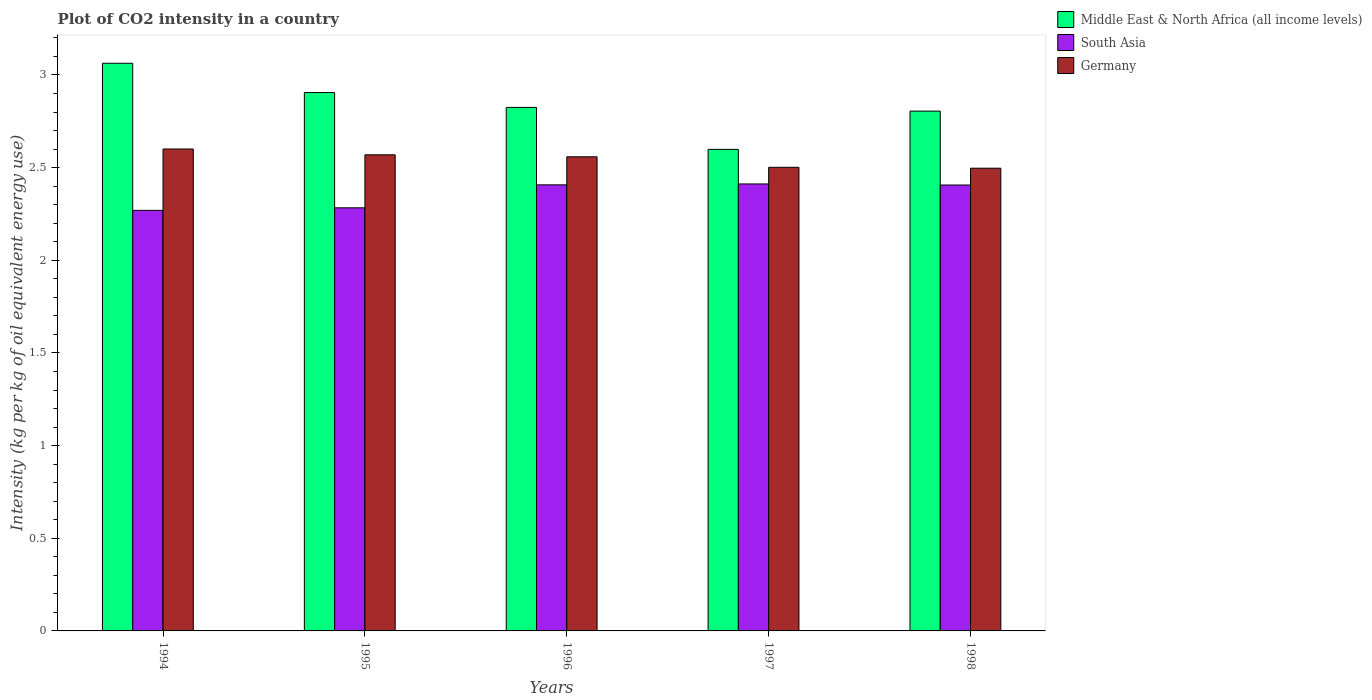How many groups of bars are there?
Your response must be concise. 5. How many bars are there on the 3rd tick from the left?
Your answer should be compact. 3. How many bars are there on the 5th tick from the right?
Your answer should be compact. 3. What is the label of the 1st group of bars from the left?
Offer a very short reply. 1994. What is the CO2 intensity in in Germany in 1996?
Your answer should be compact. 2.56. Across all years, what is the maximum CO2 intensity in in South Asia?
Your answer should be very brief. 2.41. Across all years, what is the minimum CO2 intensity in in Middle East & North Africa (all income levels)?
Offer a very short reply. 2.6. In which year was the CO2 intensity in in South Asia maximum?
Keep it short and to the point. 1997. What is the total CO2 intensity in in Germany in the graph?
Your answer should be compact. 12.73. What is the difference between the CO2 intensity in in Germany in 1995 and that in 1998?
Make the answer very short. 0.07. What is the difference between the CO2 intensity in in Germany in 1998 and the CO2 intensity in in South Asia in 1995?
Give a very brief answer. 0.21. What is the average CO2 intensity in in South Asia per year?
Ensure brevity in your answer.  2.36. In the year 1995, what is the difference between the CO2 intensity in in Middle East & North Africa (all income levels) and CO2 intensity in in South Asia?
Your response must be concise. 0.62. In how many years, is the CO2 intensity in in Germany greater than 1.1 kg?
Provide a succinct answer. 5. What is the ratio of the CO2 intensity in in Middle East & North Africa (all income levels) in 1995 to that in 1996?
Make the answer very short. 1.03. Is the CO2 intensity in in South Asia in 1997 less than that in 1998?
Ensure brevity in your answer.  No. What is the difference between the highest and the second highest CO2 intensity in in Middle East & North Africa (all income levels)?
Provide a short and direct response. 0.16. What is the difference between the highest and the lowest CO2 intensity in in Middle East & North Africa (all income levels)?
Your response must be concise. 0.46. What does the 3rd bar from the left in 1996 represents?
Your answer should be very brief. Germany. What does the 3rd bar from the right in 1997 represents?
Your answer should be very brief. Middle East & North Africa (all income levels). How many years are there in the graph?
Provide a succinct answer. 5. Are the values on the major ticks of Y-axis written in scientific E-notation?
Make the answer very short. No. What is the title of the graph?
Provide a short and direct response. Plot of CO2 intensity in a country. Does "Channel Islands" appear as one of the legend labels in the graph?
Provide a succinct answer. No. What is the label or title of the X-axis?
Your answer should be very brief. Years. What is the label or title of the Y-axis?
Offer a terse response. Intensity (kg per kg of oil equivalent energy use). What is the Intensity (kg per kg of oil equivalent energy use) in Middle East & North Africa (all income levels) in 1994?
Your answer should be compact. 3.06. What is the Intensity (kg per kg of oil equivalent energy use) in South Asia in 1994?
Keep it short and to the point. 2.27. What is the Intensity (kg per kg of oil equivalent energy use) in Germany in 1994?
Ensure brevity in your answer.  2.6. What is the Intensity (kg per kg of oil equivalent energy use) of Middle East & North Africa (all income levels) in 1995?
Give a very brief answer. 2.9. What is the Intensity (kg per kg of oil equivalent energy use) of South Asia in 1995?
Your answer should be very brief. 2.28. What is the Intensity (kg per kg of oil equivalent energy use) of Germany in 1995?
Your response must be concise. 2.57. What is the Intensity (kg per kg of oil equivalent energy use) of Middle East & North Africa (all income levels) in 1996?
Make the answer very short. 2.82. What is the Intensity (kg per kg of oil equivalent energy use) of South Asia in 1996?
Make the answer very short. 2.41. What is the Intensity (kg per kg of oil equivalent energy use) in Germany in 1996?
Your response must be concise. 2.56. What is the Intensity (kg per kg of oil equivalent energy use) of Middle East & North Africa (all income levels) in 1997?
Ensure brevity in your answer.  2.6. What is the Intensity (kg per kg of oil equivalent energy use) in South Asia in 1997?
Provide a succinct answer. 2.41. What is the Intensity (kg per kg of oil equivalent energy use) of Germany in 1997?
Your answer should be compact. 2.5. What is the Intensity (kg per kg of oil equivalent energy use) in Middle East & North Africa (all income levels) in 1998?
Offer a very short reply. 2.81. What is the Intensity (kg per kg of oil equivalent energy use) of South Asia in 1998?
Give a very brief answer. 2.41. What is the Intensity (kg per kg of oil equivalent energy use) in Germany in 1998?
Keep it short and to the point. 2.5. Across all years, what is the maximum Intensity (kg per kg of oil equivalent energy use) in Middle East & North Africa (all income levels)?
Your answer should be compact. 3.06. Across all years, what is the maximum Intensity (kg per kg of oil equivalent energy use) in South Asia?
Give a very brief answer. 2.41. Across all years, what is the maximum Intensity (kg per kg of oil equivalent energy use) in Germany?
Your answer should be compact. 2.6. Across all years, what is the minimum Intensity (kg per kg of oil equivalent energy use) of Middle East & North Africa (all income levels)?
Make the answer very short. 2.6. Across all years, what is the minimum Intensity (kg per kg of oil equivalent energy use) of South Asia?
Make the answer very short. 2.27. Across all years, what is the minimum Intensity (kg per kg of oil equivalent energy use) of Germany?
Provide a short and direct response. 2.5. What is the total Intensity (kg per kg of oil equivalent energy use) in Middle East & North Africa (all income levels) in the graph?
Keep it short and to the point. 14.2. What is the total Intensity (kg per kg of oil equivalent energy use) of South Asia in the graph?
Ensure brevity in your answer.  11.78. What is the total Intensity (kg per kg of oil equivalent energy use) of Germany in the graph?
Offer a very short reply. 12.73. What is the difference between the Intensity (kg per kg of oil equivalent energy use) in Middle East & North Africa (all income levels) in 1994 and that in 1995?
Offer a very short reply. 0.16. What is the difference between the Intensity (kg per kg of oil equivalent energy use) in South Asia in 1994 and that in 1995?
Give a very brief answer. -0.01. What is the difference between the Intensity (kg per kg of oil equivalent energy use) in Germany in 1994 and that in 1995?
Provide a succinct answer. 0.03. What is the difference between the Intensity (kg per kg of oil equivalent energy use) of Middle East & North Africa (all income levels) in 1994 and that in 1996?
Your response must be concise. 0.24. What is the difference between the Intensity (kg per kg of oil equivalent energy use) in South Asia in 1994 and that in 1996?
Make the answer very short. -0.14. What is the difference between the Intensity (kg per kg of oil equivalent energy use) in Germany in 1994 and that in 1996?
Make the answer very short. 0.04. What is the difference between the Intensity (kg per kg of oil equivalent energy use) in Middle East & North Africa (all income levels) in 1994 and that in 1997?
Make the answer very short. 0.46. What is the difference between the Intensity (kg per kg of oil equivalent energy use) of South Asia in 1994 and that in 1997?
Make the answer very short. -0.14. What is the difference between the Intensity (kg per kg of oil equivalent energy use) in Germany in 1994 and that in 1997?
Provide a short and direct response. 0.1. What is the difference between the Intensity (kg per kg of oil equivalent energy use) in Middle East & North Africa (all income levels) in 1994 and that in 1998?
Give a very brief answer. 0.26. What is the difference between the Intensity (kg per kg of oil equivalent energy use) in South Asia in 1994 and that in 1998?
Give a very brief answer. -0.14. What is the difference between the Intensity (kg per kg of oil equivalent energy use) in Germany in 1994 and that in 1998?
Offer a very short reply. 0.1. What is the difference between the Intensity (kg per kg of oil equivalent energy use) of South Asia in 1995 and that in 1996?
Your answer should be compact. -0.12. What is the difference between the Intensity (kg per kg of oil equivalent energy use) of Germany in 1995 and that in 1996?
Offer a very short reply. 0.01. What is the difference between the Intensity (kg per kg of oil equivalent energy use) in Middle East & North Africa (all income levels) in 1995 and that in 1997?
Offer a very short reply. 0.31. What is the difference between the Intensity (kg per kg of oil equivalent energy use) of South Asia in 1995 and that in 1997?
Provide a short and direct response. -0.13. What is the difference between the Intensity (kg per kg of oil equivalent energy use) in Germany in 1995 and that in 1997?
Your response must be concise. 0.07. What is the difference between the Intensity (kg per kg of oil equivalent energy use) in South Asia in 1995 and that in 1998?
Ensure brevity in your answer.  -0.12. What is the difference between the Intensity (kg per kg of oil equivalent energy use) in Germany in 1995 and that in 1998?
Your answer should be very brief. 0.07. What is the difference between the Intensity (kg per kg of oil equivalent energy use) in Middle East & North Africa (all income levels) in 1996 and that in 1997?
Your response must be concise. 0.23. What is the difference between the Intensity (kg per kg of oil equivalent energy use) of South Asia in 1996 and that in 1997?
Keep it short and to the point. -0. What is the difference between the Intensity (kg per kg of oil equivalent energy use) of Germany in 1996 and that in 1997?
Make the answer very short. 0.06. What is the difference between the Intensity (kg per kg of oil equivalent energy use) of Middle East & North Africa (all income levels) in 1996 and that in 1998?
Keep it short and to the point. 0.02. What is the difference between the Intensity (kg per kg of oil equivalent energy use) of South Asia in 1996 and that in 1998?
Offer a very short reply. 0. What is the difference between the Intensity (kg per kg of oil equivalent energy use) of Germany in 1996 and that in 1998?
Make the answer very short. 0.06. What is the difference between the Intensity (kg per kg of oil equivalent energy use) of Middle East & North Africa (all income levels) in 1997 and that in 1998?
Make the answer very short. -0.21. What is the difference between the Intensity (kg per kg of oil equivalent energy use) in South Asia in 1997 and that in 1998?
Keep it short and to the point. 0.01. What is the difference between the Intensity (kg per kg of oil equivalent energy use) of Germany in 1997 and that in 1998?
Give a very brief answer. 0. What is the difference between the Intensity (kg per kg of oil equivalent energy use) of Middle East & North Africa (all income levels) in 1994 and the Intensity (kg per kg of oil equivalent energy use) of South Asia in 1995?
Give a very brief answer. 0.78. What is the difference between the Intensity (kg per kg of oil equivalent energy use) of Middle East & North Africa (all income levels) in 1994 and the Intensity (kg per kg of oil equivalent energy use) of Germany in 1995?
Ensure brevity in your answer.  0.49. What is the difference between the Intensity (kg per kg of oil equivalent energy use) in Middle East & North Africa (all income levels) in 1994 and the Intensity (kg per kg of oil equivalent energy use) in South Asia in 1996?
Keep it short and to the point. 0.66. What is the difference between the Intensity (kg per kg of oil equivalent energy use) in Middle East & North Africa (all income levels) in 1994 and the Intensity (kg per kg of oil equivalent energy use) in Germany in 1996?
Keep it short and to the point. 0.5. What is the difference between the Intensity (kg per kg of oil equivalent energy use) of South Asia in 1994 and the Intensity (kg per kg of oil equivalent energy use) of Germany in 1996?
Make the answer very short. -0.29. What is the difference between the Intensity (kg per kg of oil equivalent energy use) of Middle East & North Africa (all income levels) in 1994 and the Intensity (kg per kg of oil equivalent energy use) of South Asia in 1997?
Keep it short and to the point. 0.65. What is the difference between the Intensity (kg per kg of oil equivalent energy use) in Middle East & North Africa (all income levels) in 1994 and the Intensity (kg per kg of oil equivalent energy use) in Germany in 1997?
Keep it short and to the point. 0.56. What is the difference between the Intensity (kg per kg of oil equivalent energy use) in South Asia in 1994 and the Intensity (kg per kg of oil equivalent energy use) in Germany in 1997?
Make the answer very short. -0.23. What is the difference between the Intensity (kg per kg of oil equivalent energy use) of Middle East & North Africa (all income levels) in 1994 and the Intensity (kg per kg of oil equivalent energy use) of South Asia in 1998?
Your response must be concise. 0.66. What is the difference between the Intensity (kg per kg of oil equivalent energy use) in Middle East & North Africa (all income levels) in 1994 and the Intensity (kg per kg of oil equivalent energy use) in Germany in 1998?
Provide a short and direct response. 0.57. What is the difference between the Intensity (kg per kg of oil equivalent energy use) of South Asia in 1994 and the Intensity (kg per kg of oil equivalent energy use) of Germany in 1998?
Your response must be concise. -0.23. What is the difference between the Intensity (kg per kg of oil equivalent energy use) in Middle East & North Africa (all income levels) in 1995 and the Intensity (kg per kg of oil equivalent energy use) in South Asia in 1996?
Your answer should be compact. 0.5. What is the difference between the Intensity (kg per kg of oil equivalent energy use) of Middle East & North Africa (all income levels) in 1995 and the Intensity (kg per kg of oil equivalent energy use) of Germany in 1996?
Ensure brevity in your answer.  0.35. What is the difference between the Intensity (kg per kg of oil equivalent energy use) of South Asia in 1995 and the Intensity (kg per kg of oil equivalent energy use) of Germany in 1996?
Ensure brevity in your answer.  -0.28. What is the difference between the Intensity (kg per kg of oil equivalent energy use) in Middle East & North Africa (all income levels) in 1995 and the Intensity (kg per kg of oil equivalent energy use) in South Asia in 1997?
Ensure brevity in your answer.  0.49. What is the difference between the Intensity (kg per kg of oil equivalent energy use) in Middle East & North Africa (all income levels) in 1995 and the Intensity (kg per kg of oil equivalent energy use) in Germany in 1997?
Offer a very short reply. 0.4. What is the difference between the Intensity (kg per kg of oil equivalent energy use) of South Asia in 1995 and the Intensity (kg per kg of oil equivalent energy use) of Germany in 1997?
Your answer should be very brief. -0.22. What is the difference between the Intensity (kg per kg of oil equivalent energy use) in Middle East & North Africa (all income levels) in 1995 and the Intensity (kg per kg of oil equivalent energy use) in South Asia in 1998?
Provide a succinct answer. 0.5. What is the difference between the Intensity (kg per kg of oil equivalent energy use) in Middle East & North Africa (all income levels) in 1995 and the Intensity (kg per kg of oil equivalent energy use) in Germany in 1998?
Offer a very short reply. 0.41. What is the difference between the Intensity (kg per kg of oil equivalent energy use) in South Asia in 1995 and the Intensity (kg per kg of oil equivalent energy use) in Germany in 1998?
Offer a very short reply. -0.21. What is the difference between the Intensity (kg per kg of oil equivalent energy use) in Middle East & North Africa (all income levels) in 1996 and the Intensity (kg per kg of oil equivalent energy use) in South Asia in 1997?
Your response must be concise. 0.41. What is the difference between the Intensity (kg per kg of oil equivalent energy use) in Middle East & North Africa (all income levels) in 1996 and the Intensity (kg per kg of oil equivalent energy use) in Germany in 1997?
Provide a short and direct response. 0.32. What is the difference between the Intensity (kg per kg of oil equivalent energy use) of South Asia in 1996 and the Intensity (kg per kg of oil equivalent energy use) of Germany in 1997?
Keep it short and to the point. -0.09. What is the difference between the Intensity (kg per kg of oil equivalent energy use) in Middle East & North Africa (all income levels) in 1996 and the Intensity (kg per kg of oil equivalent energy use) in South Asia in 1998?
Your answer should be compact. 0.42. What is the difference between the Intensity (kg per kg of oil equivalent energy use) of Middle East & North Africa (all income levels) in 1996 and the Intensity (kg per kg of oil equivalent energy use) of Germany in 1998?
Keep it short and to the point. 0.33. What is the difference between the Intensity (kg per kg of oil equivalent energy use) of South Asia in 1996 and the Intensity (kg per kg of oil equivalent energy use) of Germany in 1998?
Offer a very short reply. -0.09. What is the difference between the Intensity (kg per kg of oil equivalent energy use) in Middle East & North Africa (all income levels) in 1997 and the Intensity (kg per kg of oil equivalent energy use) in South Asia in 1998?
Keep it short and to the point. 0.19. What is the difference between the Intensity (kg per kg of oil equivalent energy use) in Middle East & North Africa (all income levels) in 1997 and the Intensity (kg per kg of oil equivalent energy use) in Germany in 1998?
Give a very brief answer. 0.1. What is the difference between the Intensity (kg per kg of oil equivalent energy use) in South Asia in 1997 and the Intensity (kg per kg of oil equivalent energy use) in Germany in 1998?
Make the answer very short. -0.08. What is the average Intensity (kg per kg of oil equivalent energy use) in Middle East & North Africa (all income levels) per year?
Make the answer very short. 2.84. What is the average Intensity (kg per kg of oil equivalent energy use) in South Asia per year?
Your answer should be very brief. 2.36. What is the average Intensity (kg per kg of oil equivalent energy use) in Germany per year?
Offer a very short reply. 2.55. In the year 1994, what is the difference between the Intensity (kg per kg of oil equivalent energy use) in Middle East & North Africa (all income levels) and Intensity (kg per kg of oil equivalent energy use) in South Asia?
Keep it short and to the point. 0.79. In the year 1994, what is the difference between the Intensity (kg per kg of oil equivalent energy use) of Middle East & North Africa (all income levels) and Intensity (kg per kg of oil equivalent energy use) of Germany?
Provide a short and direct response. 0.46. In the year 1994, what is the difference between the Intensity (kg per kg of oil equivalent energy use) in South Asia and Intensity (kg per kg of oil equivalent energy use) in Germany?
Make the answer very short. -0.33. In the year 1995, what is the difference between the Intensity (kg per kg of oil equivalent energy use) of Middle East & North Africa (all income levels) and Intensity (kg per kg of oil equivalent energy use) of South Asia?
Offer a terse response. 0.62. In the year 1995, what is the difference between the Intensity (kg per kg of oil equivalent energy use) in Middle East & North Africa (all income levels) and Intensity (kg per kg of oil equivalent energy use) in Germany?
Keep it short and to the point. 0.34. In the year 1995, what is the difference between the Intensity (kg per kg of oil equivalent energy use) in South Asia and Intensity (kg per kg of oil equivalent energy use) in Germany?
Keep it short and to the point. -0.29. In the year 1996, what is the difference between the Intensity (kg per kg of oil equivalent energy use) of Middle East & North Africa (all income levels) and Intensity (kg per kg of oil equivalent energy use) of South Asia?
Make the answer very short. 0.42. In the year 1996, what is the difference between the Intensity (kg per kg of oil equivalent energy use) of Middle East & North Africa (all income levels) and Intensity (kg per kg of oil equivalent energy use) of Germany?
Your answer should be compact. 0.27. In the year 1996, what is the difference between the Intensity (kg per kg of oil equivalent energy use) of South Asia and Intensity (kg per kg of oil equivalent energy use) of Germany?
Provide a short and direct response. -0.15. In the year 1997, what is the difference between the Intensity (kg per kg of oil equivalent energy use) of Middle East & North Africa (all income levels) and Intensity (kg per kg of oil equivalent energy use) of South Asia?
Ensure brevity in your answer.  0.19. In the year 1997, what is the difference between the Intensity (kg per kg of oil equivalent energy use) of Middle East & North Africa (all income levels) and Intensity (kg per kg of oil equivalent energy use) of Germany?
Offer a very short reply. 0.1. In the year 1997, what is the difference between the Intensity (kg per kg of oil equivalent energy use) in South Asia and Intensity (kg per kg of oil equivalent energy use) in Germany?
Make the answer very short. -0.09. In the year 1998, what is the difference between the Intensity (kg per kg of oil equivalent energy use) of Middle East & North Africa (all income levels) and Intensity (kg per kg of oil equivalent energy use) of South Asia?
Offer a very short reply. 0.4. In the year 1998, what is the difference between the Intensity (kg per kg of oil equivalent energy use) of Middle East & North Africa (all income levels) and Intensity (kg per kg of oil equivalent energy use) of Germany?
Keep it short and to the point. 0.31. In the year 1998, what is the difference between the Intensity (kg per kg of oil equivalent energy use) of South Asia and Intensity (kg per kg of oil equivalent energy use) of Germany?
Your answer should be compact. -0.09. What is the ratio of the Intensity (kg per kg of oil equivalent energy use) in Middle East & North Africa (all income levels) in 1994 to that in 1995?
Keep it short and to the point. 1.05. What is the ratio of the Intensity (kg per kg of oil equivalent energy use) of Germany in 1994 to that in 1995?
Keep it short and to the point. 1.01. What is the ratio of the Intensity (kg per kg of oil equivalent energy use) in Middle East & North Africa (all income levels) in 1994 to that in 1996?
Offer a terse response. 1.08. What is the ratio of the Intensity (kg per kg of oil equivalent energy use) of South Asia in 1994 to that in 1996?
Offer a very short reply. 0.94. What is the ratio of the Intensity (kg per kg of oil equivalent energy use) of Germany in 1994 to that in 1996?
Give a very brief answer. 1.02. What is the ratio of the Intensity (kg per kg of oil equivalent energy use) of Middle East & North Africa (all income levels) in 1994 to that in 1997?
Your response must be concise. 1.18. What is the ratio of the Intensity (kg per kg of oil equivalent energy use) of South Asia in 1994 to that in 1997?
Give a very brief answer. 0.94. What is the ratio of the Intensity (kg per kg of oil equivalent energy use) of Germany in 1994 to that in 1997?
Provide a succinct answer. 1.04. What is the ratio of the Intensity (kg per kg of oil equivalent energy use) of Middle East & North Africa (all income levels) in 1994 to that in 1998?
Your answer should be very brief. 1.09. What is the ratio of the Intensity (kg per kg of oil equivalent energy use) of South Asia in 1994 to that in 1998?
Offer a terse response. 0.94. What is the ratio of the Intensity (kg per kg of oil equivalent energy use) in Germany in 1994 to that in 1998?
Ensure brevity in your answer.  1.04. What is the ratio of the Intensity (kg per kg of oil equivalent energy use) of Middle East & North Africa (all income levels) in 1995 to that in 1996?
Provide a succinct answer. 1.03. What is the ratio of the Intensity (kg per kg of oil equivalent energy use) of South Asia in 1995 to that in 1996?
Offer a very short reply. 0.95. What is the ratio of the Intensity (kg per kg of oil equivalent energy use) in Middle East & North Africa (all income levels) in 1995 to that in 1997?
Offer a terse response. 1.12. What is the ratio of the Intensity (kg per kg of oil equivalent energy use) in South Asia in 1995 to that in 1997?
Make the answer very short. 0.95. What is the ratio of the Intensity (kg per kg of oil equivalent energy use) in Germany in 1995 to that in 1997?
Give a very brief answer. 1.03. What is the ratio of the Intensity (kg per kg of oil equivalent energy use) in Middle East & North Africa (all income levels) in 1995 to that in 1998?
Make the answer very short. 1.04. What is the ratio of the Intensity (kg per kg of oil equivalent energy use) in South Asia in 1995 to that in 1998?
Provide a short and direct response. 0.95. What is the ratio of the Intensity (kg per kg of oil equivalent energy use) of Middle East & North Africa (all income levels) in 1996 to that in 1997?
Offer a terse response. 1.09. What is the ratio of the Intensity (kg per kg of oil equivalent energy use) of South Asia in 1996 to that in 1997?
Offer a very short reply. 1. What is the ratio of the Intensity (kg per kg of oil equivalent energy use) in Germany in 1996 to that in 1997?
Your answer should be compact. 1.02. What is the ratio of the Intensity (kg per kg of oil equivalent energy use) of Middle East & North Africa (all income levels) in 1996 to that in 1998?
Provide a short and direct response. 1.01. What is the ratio of the Intensity (kg per kg of oil equivalent energy use) in Germany in 1996 to that in 1998?
Your answer should be very brief. 1.02. What is the ratio of the Intensity (kg per kg of oil equivalent energy use) in Middle East & North Africa (all income levels) in 1997 to that in 1998?
Your answer should be compact. 0.93. What is the ratio of the Intensity (kg per kg of oil equivalent energy use) of Germany in 1997 to that in 1998?
Your response must be concise. 1. What is the difference between the highest and the second highest Intensity (kg per kg of oil equivalent energy use) in Middle East & North Africa (all income levels)?
Offer a terse response. 0.16. What is the difference between the highest and the second highest Intensity (kg per kg of oil equivalent energy use) in South Asia?
Ensure brevity in your answer.  0. What is the difference between the highest and the second highest Intensity (kg per kg of oil equivalent energy use) in Germany?
Keep it short and to the point. 0.03. What is the difference between the highest and the lowest Intensity (kg per kg of oil equivalent energy use) in Middle East & North Africa (all income levels)?
Provide a short and direct response. 0.46. What is the difference between the highest and the lowest Intensity (kg per kg of oil equivalent energy use) in South Asia?
Make the answer very short. 0.14. What is the difference between the highest and the lowest Intensity (kg per kg of oil equivalent energy use) in Germany?
Offer a terse response. 0.1. 